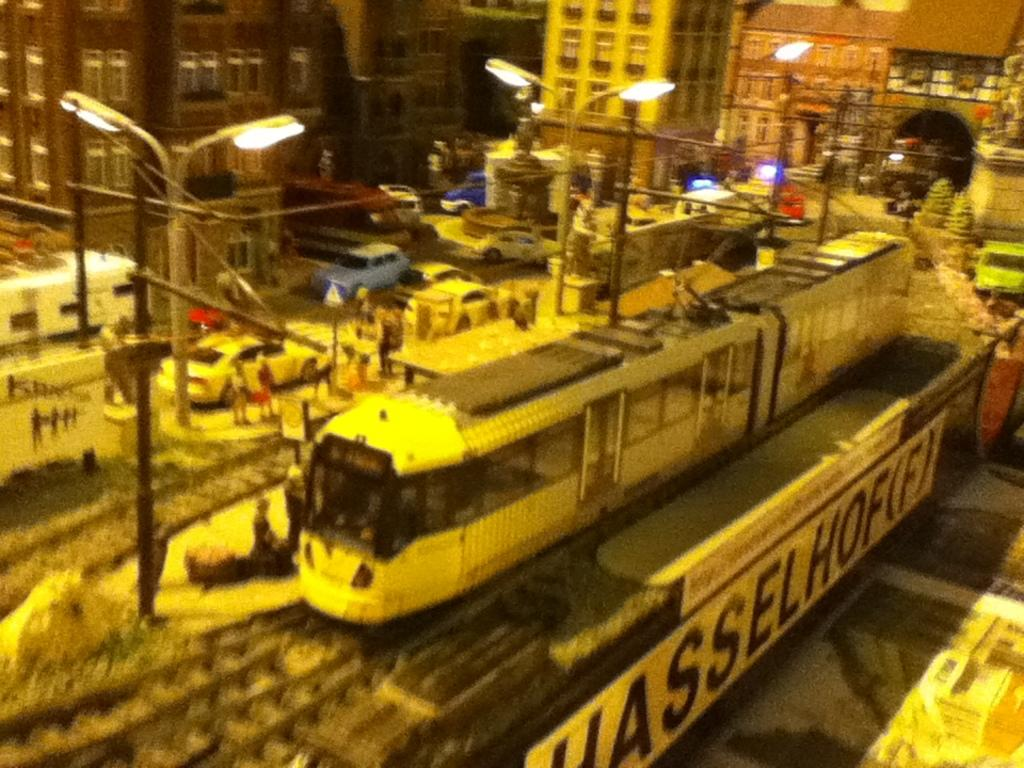<image>
Provide a brief description of the given image. A city scene model train set with a Hasselhof(f) sticker. 